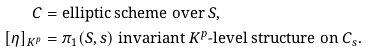<formula> <loc_0><loc_0><loc_500><loc_500>C & = \text {elliptic scheme over $S$,} \\ [ \eta ] _ { K ^ { p } } & = \text {$\pi_{1}(S,s)$ invariant $K^{p}$-level structure on $C_{s}$.}</formula> 